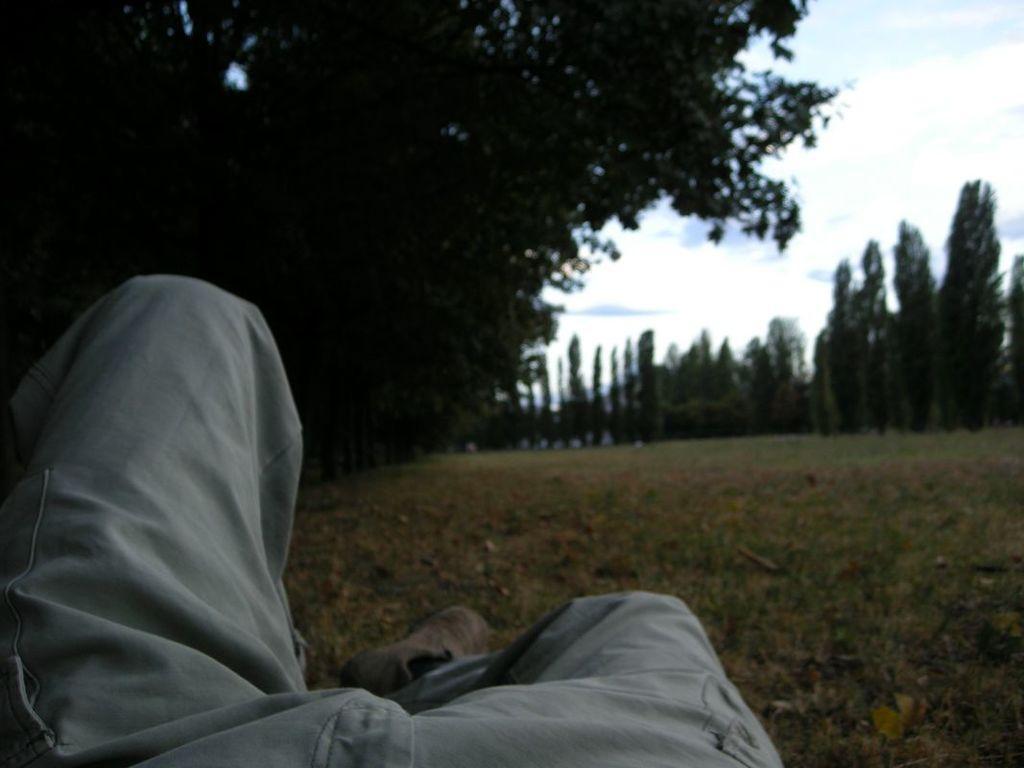In one or two sentences, can you explain what this image depicts? In this image we can see the legs of a person. We can also see some grass, a group of trees and the sky which looks cloudy. 